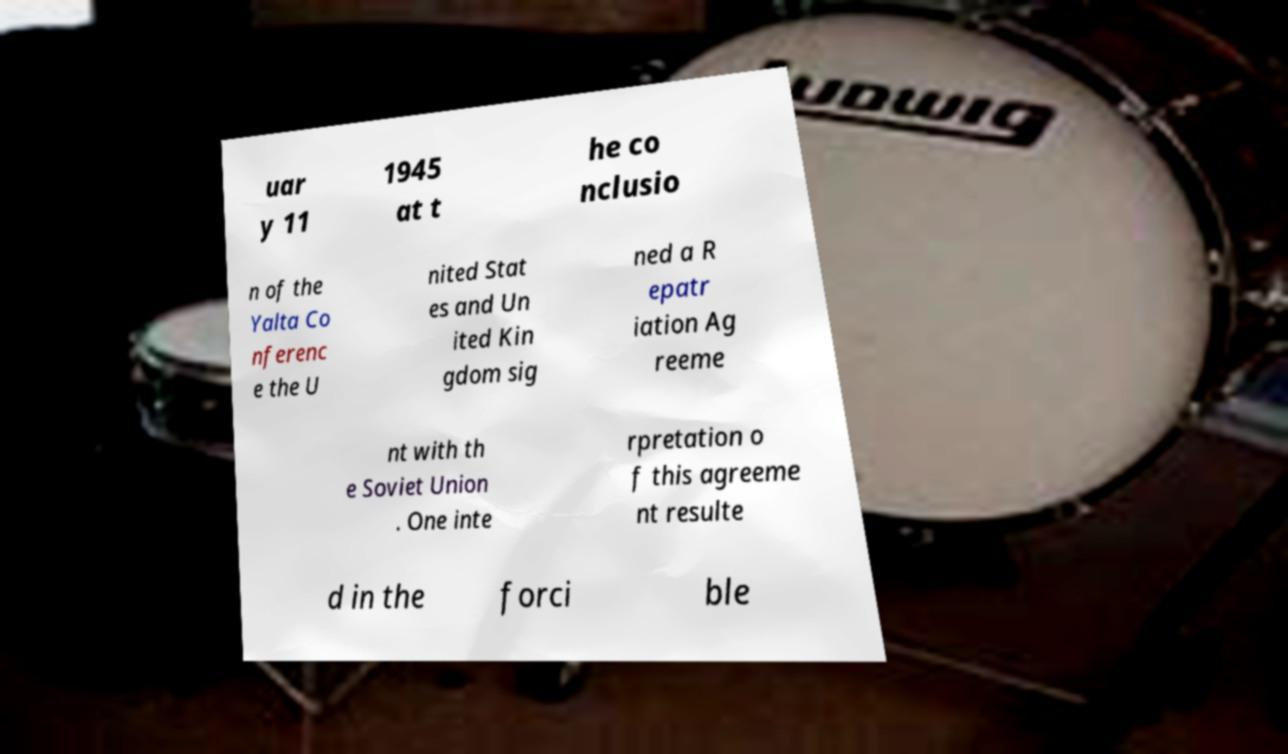For documentation purposes, I need the text within this image transcribed. Could you provide that? uar y 11 1945 at t he co nclusio n of the Yalta Co nferenc e the U nited Stat es and Un ited Kin gdom sig ned a R epatr iation Ag reeme nt with th e Soviet Union . One inte rpretation o f this agreeme nt resulte d in the forci ble 